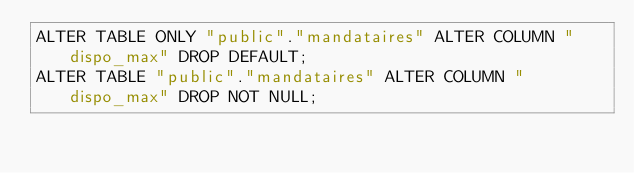<code> <loc_0><loc_0><loc_500><loc_500><_SQL_>ALTER TABLE ONLY "public"."mandataires" ALTER COLUMN "dispo_max" DROP DEFAULT;
ALTER TABLE "public"."mandataires" ALTER COLUMN "dispo_max" DROP NOT NULL;
</code> 